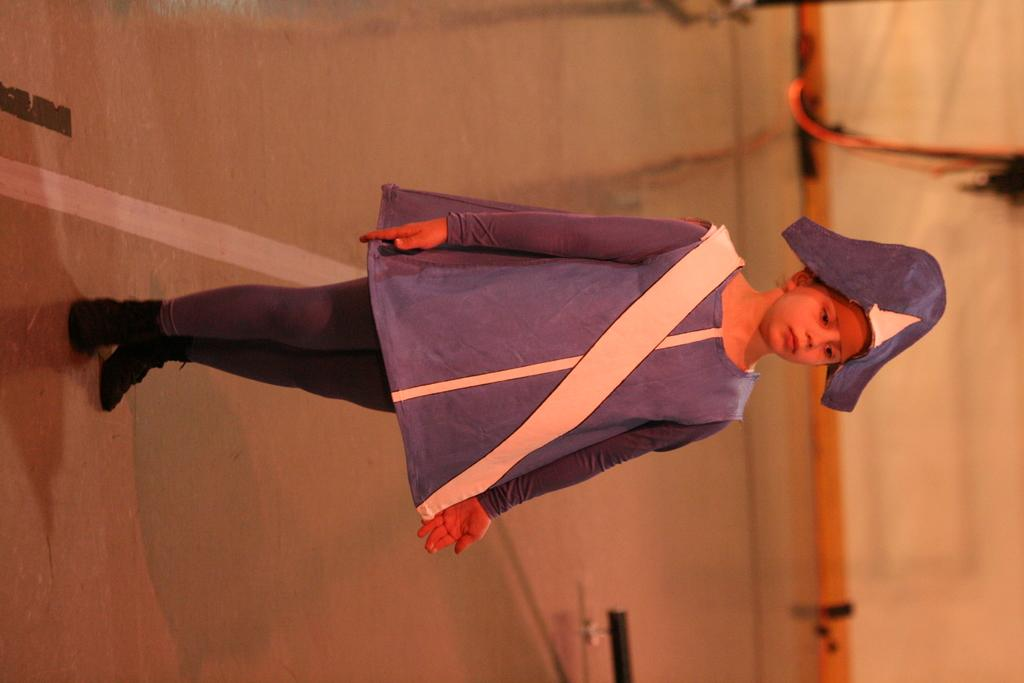What is the main subject of the image? The main subject of the image is a kid standing on the floor. What can be seen on the floor in the image? There are white and black lines visible on the floor in the image. What is located on the right side of the image? There are objects on the right side of the image. Can you tell me how many tigers are walking in the bedroom in the image? There are no tigers or bedrooms present in the image; it features a kid standing on the floor with white and black lines on it, and objects on the right side. 